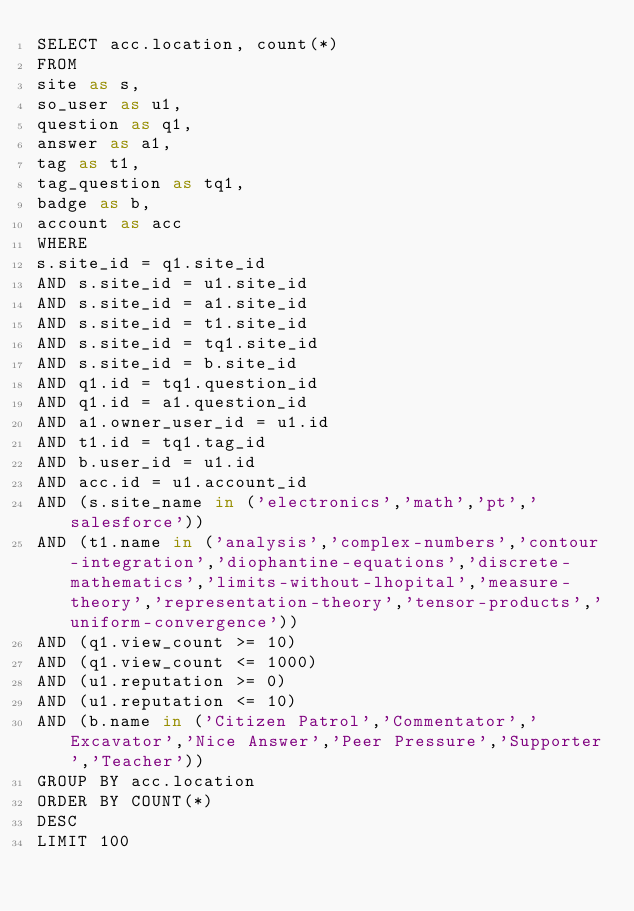<code> <loc_0><loc_0><loc_500><loc_500><_SQL_>SELECT acc.location, count(*)
FROM
site as s,
so_user as u1,
question as q1,
answer as a1,
tag as t1,
tag_question as tq1,
badge as b,
account as acc
WHERE
s.site_id = q1.site_id
AND s.site_id = u1.site_id
AND s.site_id = a1.site_id
AND s.site_id = t1.site_id
AND s.site_id = tq1.site_id
AND s.site_id = b.site_id
AND q1.id = tq1.question_id
AND q1.id = a1.question_id
AND a1.owner_user_id = u1.id
AND t1.id = tq1.tag_id
AND b.user_id = u1.id
AND acc.id = u1.account_id
AND (s.site_name in ('electronics','math','pt','salesforce'))
AND (t1.name in ('analysis','complex-numbers','contour-integration','diophantine-equations','discrete-mathematics','limits-without-lhopital','measure-theory','representation-theory','tensor-products','uniform-convergence'))
AND (q1.view_count >= 10)
AND (q1.view_count <= 1000)
AND (u1.reputation >= 0)
AND (u1.reputation <= 10)
AND (b.name in ('Citizen Patrol','Commentator','Excavator','Nice Answer','Peer Pressure','Supporter','Teacher'))
GROUP BY acc.location
ORDER BY COUNT(*)
DESC
LIMIT 100
</code> 